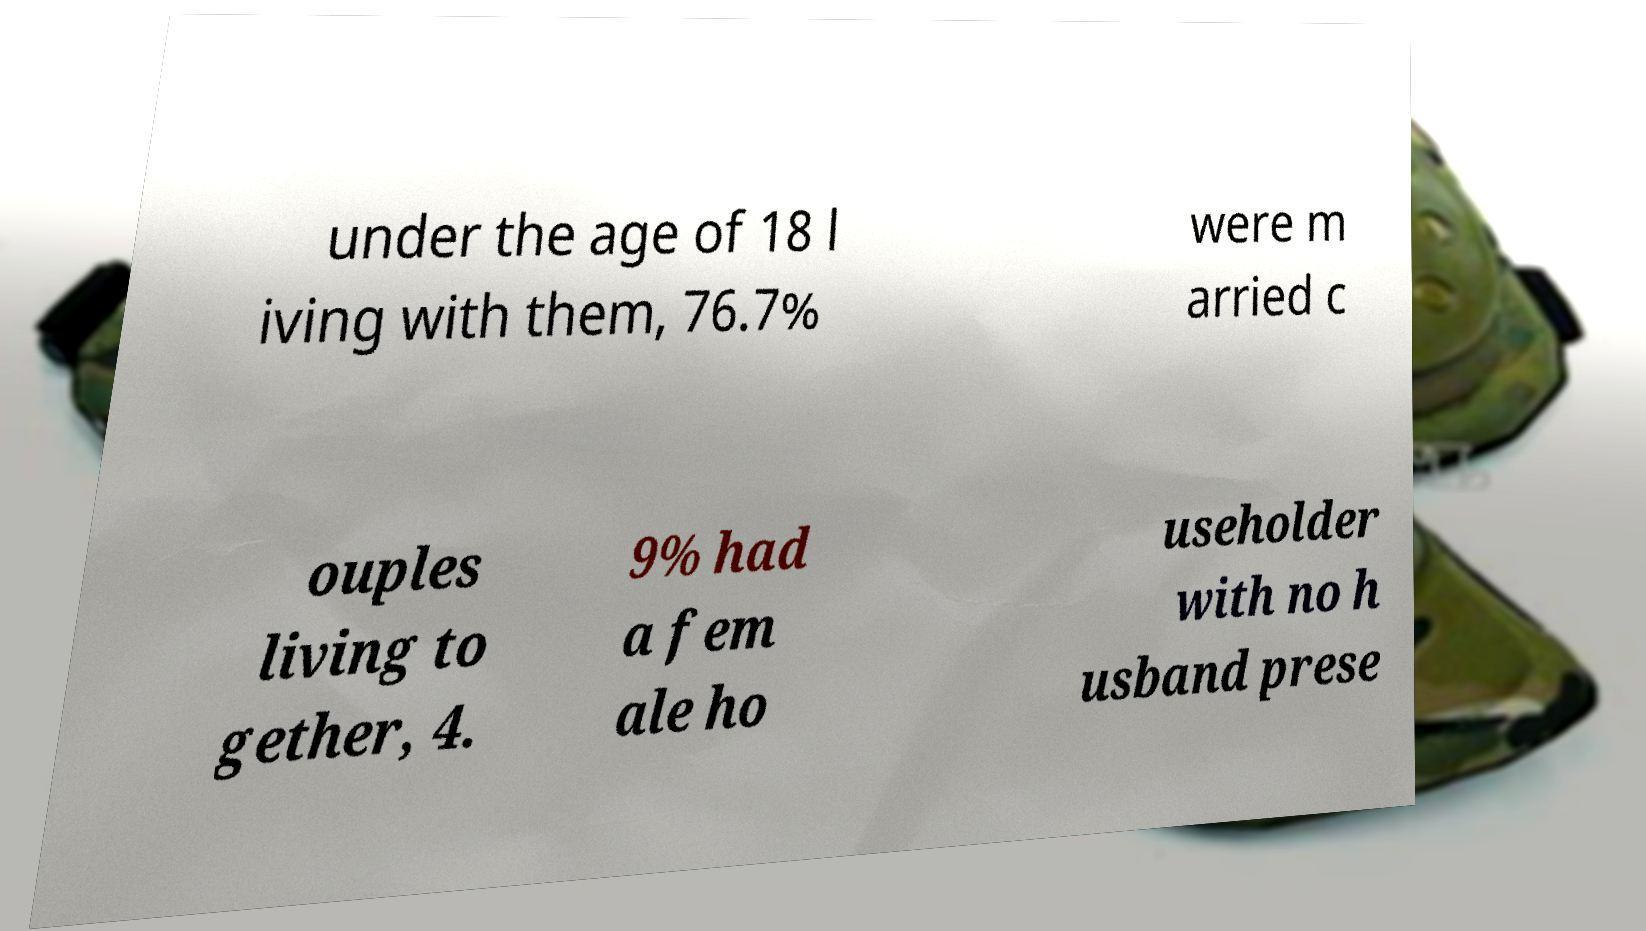What messages or text are displayed in this image? I need them in a readable, typed format. under the age of 18 l iving with them, 76.7% were m arried c ouples living to gether, 4. 9% had a fem ale ho useholder with no h usband prese 